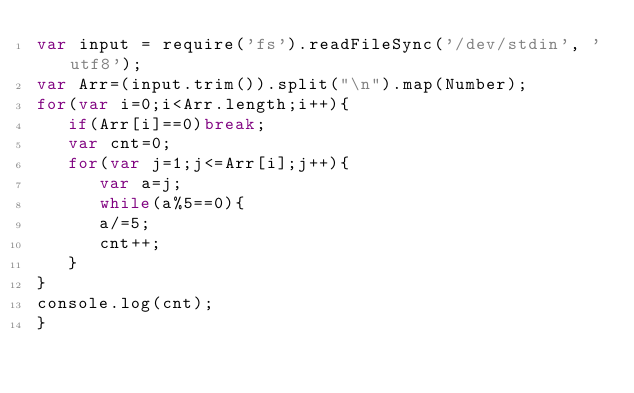<code> <loc_0><loc_0><loc_500><loc_500><_JavaScript_>var input = require('fs').readFileSync('/dev/stdin', 'utf8');
var Arr=(input.trim()).split("\n").map(Number);
for(var i=0;i<Arr.length;i++){
   if(Arr[i]==0)break;
   var cnt=0;
   for(var j=1;j<=Arr[i];j++){
      var a=j;
      while(a%5==0){
      a/=5;
      cnt++;
   }
}
console.log(cnt);
}</code> 